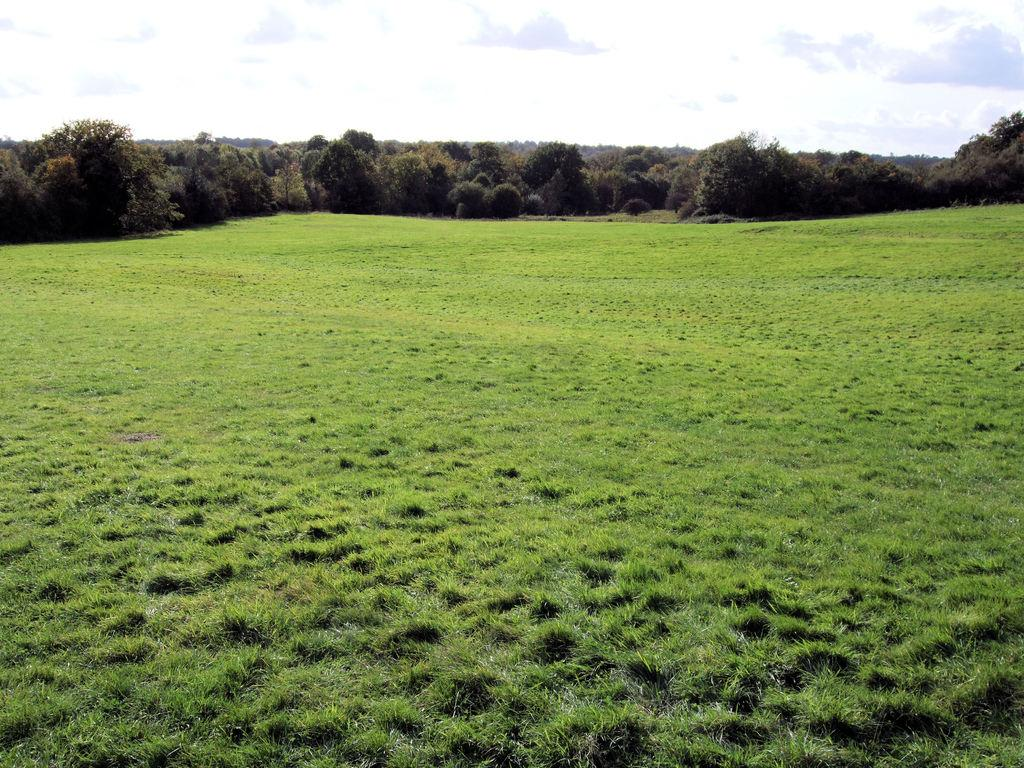What type of natural environment is depicted in the image? There is greenery in the image, suggesting a natural environment. What is visible at the top of the image? The sky is visible at the top of the image. How many markets are present in the image? There is no mention of a market in the image, so it is not possible to determine the number of markets present. 